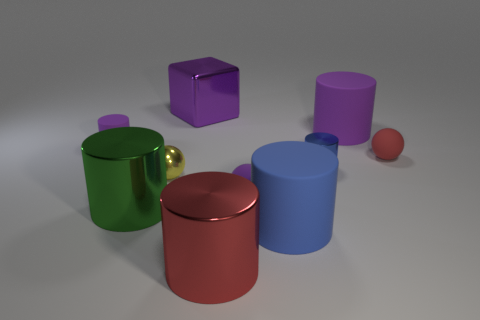Do the yellow ball and the ball in front of the small yellow sphere have the same material? Based on the visual properties observed in the image, the yellow ball and the ball in front of the small yellow sphere appear to have different materials. The yellow ball exhibits a matte finish, absorbing most of the light, while the other ball has a reflective surface, suggesting it is possibly made of a polished or metallic material. 